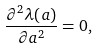Convert formula to latex. <formula><loc_0><loc_0><loc_500><loc_500>\frac { \partial ^ { 2 } \lambda ( a ) } { \partial a ^ { 2 } } = 0 ,</formula> 